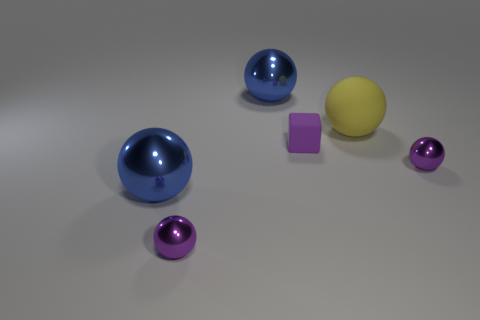Is there anything else that has the same material as the small purple block?
Provide a short and direct response. Yes. There is a yellow rubber ball; what number of large rubber spheres are behind it?
Your response must be concise. 0. What is the size of the object that is both in front of the yellow rubber sphere and on the right side of the small rubber block?
Offer a very short reply. Small. Does the big rubber object have the same color as the tiny metal ball on the right side of the yellow matte object?
Provide a succinct answer. No. How many yellow things are small metal balls or large matte objects?
Ensure brevity in your answer.  1. The tiny purple matte thing has what shape?
Give a very brief answer. Cube. How many other objects are there of the same shape as the yellow thing?
Offer a very short reply. 4. There is a tiny object that is left of the tiny purple rubber object; what is its color?
Give a very brief answer. Purple. Do the tiny cube and the large yellow ball have the same material?
Provide a succinct answer. Yes. How many objects are either rubber blocks or big metallic spheres that are behind the small rubber cube?
Provide a succinct answer. 2. 